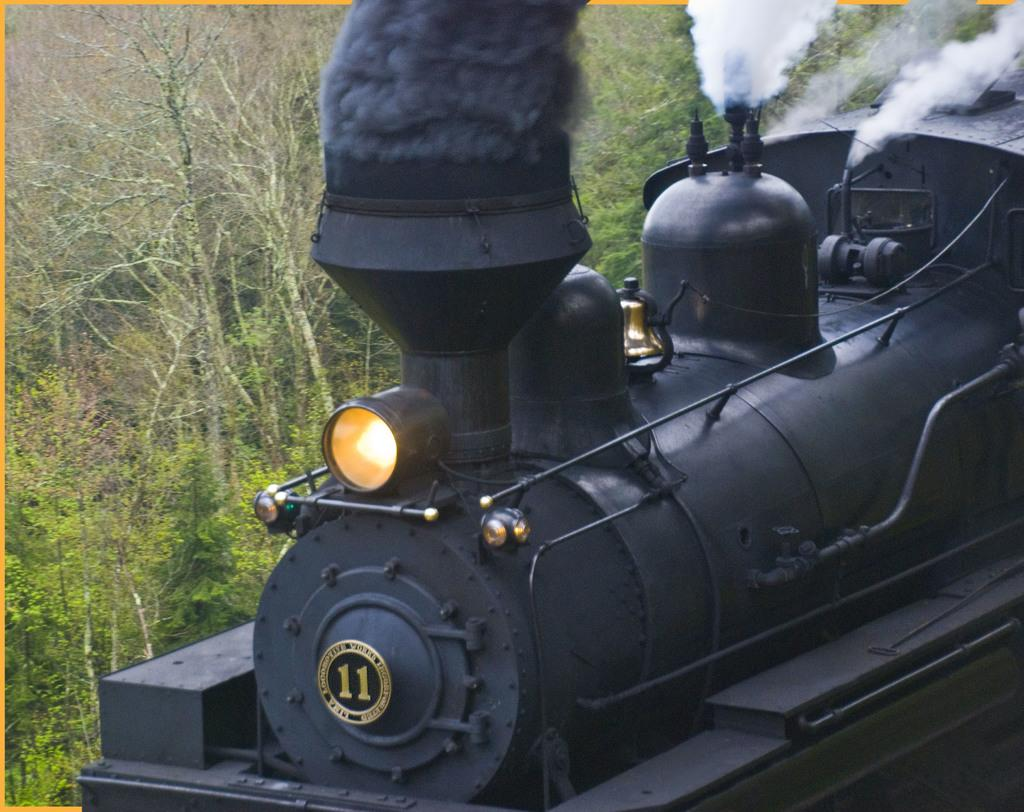Provide a one-sentence caption for the provided image. A train engine producing steam labeled number 11. 